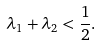<formula> <loc_0><loc_0><loc_500><loc_500>\lambda _ { 1 } + \lambda _ { 2 } < \frac { 1 } { 2 } .</formula> 